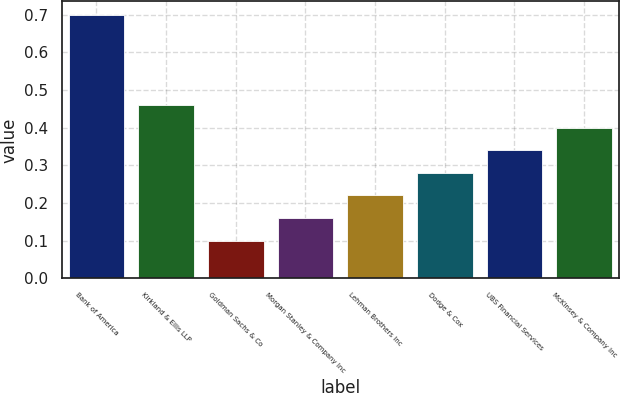<chart> <loc_0><loc_0><loc_500><loc_500><bar_chart><fcel>Bank of America<fcel>Kirkland & Ellis LLP<fcel>Goldman Sachs & Co<fcel>Morgan Stanley & Company Inc<fcel>Lehman Brothers Inc<fcel>Dodge & Cox<fcel>UBS Financial Services<fcel>McKinsey & Company Inc<nl><fcel>0.7<fcel>0.46<fcel>0.1<fcel>0.16<fcel>0.22<fcel>0.28<fcel>0.34<fcel>0.4<nl></chart> 